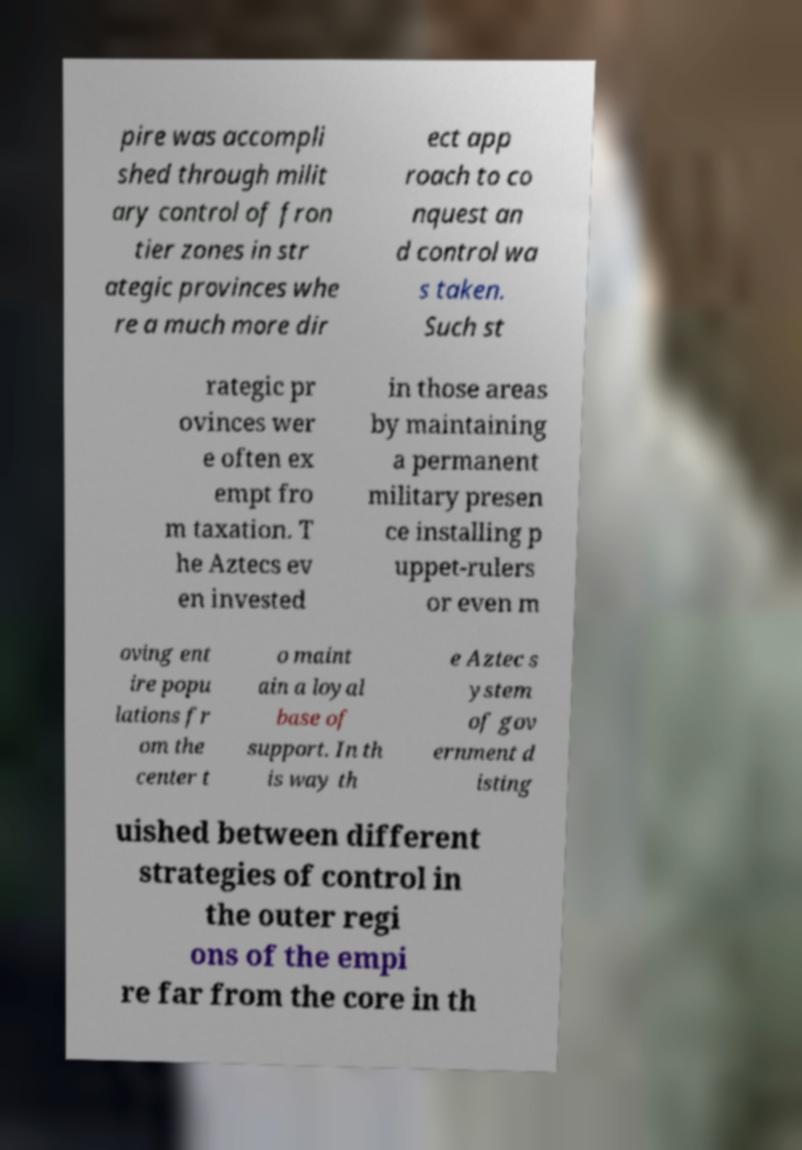Could you assist in decoding the text presented in this image and type it out clearly? pire was accompli shed through milit ary control of fron tier zones in str ategic provinces whe re a much more dir ect app roach to co nquest an d control wa s taken. Such st rategic pr ovinces wer e often ex empt fro m taxation. T he Aztecs ev en invested in those areas by maintaining a permanent military presen ce installing p uppet-rulers or even m oving ent ire popu lations fr om the center t o maint ain a loyal base of support. In th is way th e Aztec s ystem of gov ernment d isting uished between different strategies of control in the outer regi ons of the empi re far from the core in th 